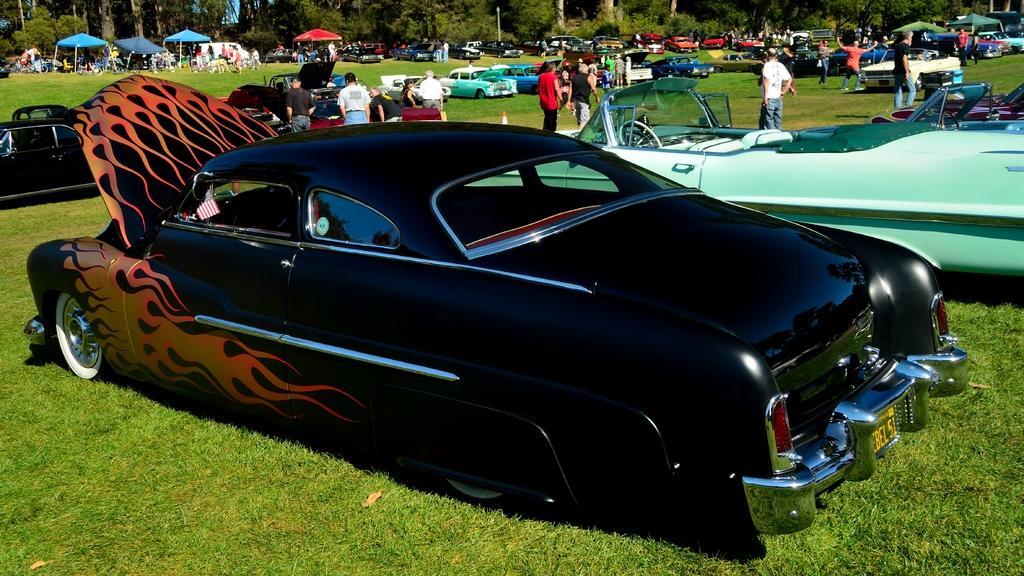Could you give a brief overview of what you see in this image? As we can see in the image there is grass, cars, few people here and there, trees and tents in the background. 